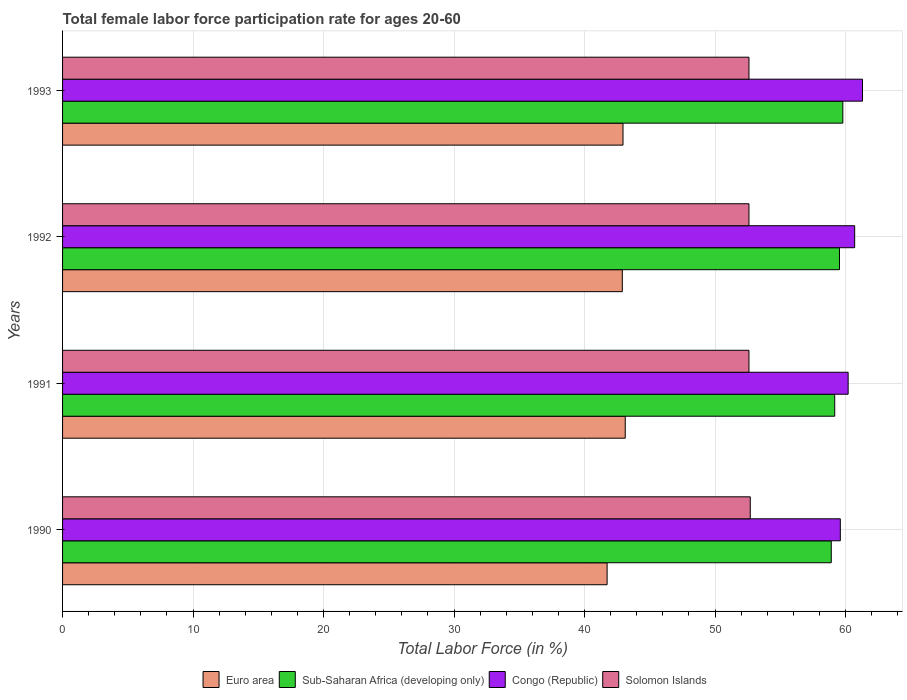How many groups of bars are there?
Provide a succinct answer. 4. Are the number of bars per tick equal to the number of legend labels?
Ensure brevity in your answer.  Yes. How many bars are there on the 1st tick from the top?
Keep it short and to the point. 4. What is the female labor force participation rate in Congo (Republic) in 1992?
Keep it short and to the point. 60.7. Across all years, what is the maximum female labor force participation rate in Euro area?
Provide a short and direct response. 43.12. Across all years, what is the minimum female labor force participation rate in Solomon Islands?
Provide a succinct answer. 52.6. What is the total female labor force participation rate in Congo (Republic) in the graph?
Provide a short and direct response. 241.8. What is the difference between the female labor force participation rate in Sub-Saharan Africa (developing only) in 1990 and that in 1993?
Offer a very short reply. -0.89. What is the difference between the female labor force participation rate in Congo (Republic) in 1990 and the female labor force participation rate in Euro area in 1992?
Give a very brief answer. 16.71. What is the average female labor force participation rate in Congo (Republic) per year?
Make the answer very short. 60.45. In the year 1992, what is the difference between the female labor force participation rate in Sub-Saharan Africa (developing only) and female labor force participation rate in Solomon Islands?
Make the answer very short. 6.94. Is the difference between the female labor force participation rate in Sub-Saharan Africa (developing only) in 1990 and 1993 greater than the difference between the female labor force participation rate in Solomon Islands in 1990 and 1993?
Offer a terse response. No. What is the difference between the highest and the second highest female labor force participation rate in Sub-Saharan Africa (developing only)?
Your response must be concise. 0.26. What is the difference between the highest and the lowest female labor force participation rate in Euro area?
Your response must be concise. 1.39. In how many years, is the female labor force participation rate in Sub-Saharan Africa (developing only) greater than the average female labor force participation rate in Sub-Saharan Africa (developing only) taken over all years?
Offer a terse response. 2. Is the sum of the female labor force participation rate in Sub-Saharan Africa (developing only) in 1990 and 1993 greater than the maximum female labor force participation rate in Euro area across all years?
Your answer should be compact. Yes. Is it the case that in every year, the sum of the female labor force participation rate in Sub-Saharan Africa (developing only) and female labor force participation rate in Congo (Republic) is greater than the sum of female labor force participation rate in Euro area and female labor force participation rate in Solomon Islands?
Give a very brief answer. Yes. What does the 2nd bar from the top in 1993 represents?
Provide a succinct answer. Congo (Republic). What does the 3rd bar from the bottom in 1992 represents?
Keep it short and to the point. Congo (Republic). How many bars are there?
Your answer should be compact. 16. How many years are there in the graph?
Your response must be concise. 4. What is the difference between two consecutive major ticks on the X-axis?
Your response must be concise. 10. Are the values on the major ticks of X-axis written in scientific E-notation?
Keep it short and to the point. No. Does the graph contain any zero values?
Your answer should be compact. No. Does the graph contain grids?
Your answer should be compact. Yes. How many legend labels are there?
Offer a terse response. 4. What is the title of the graph?
Ensure brevity in your answer.  Total female labor force participation rate for ages 20-60. Does "India" appear as one of the legend labels in the graph?
Your response must be concise. No. What is the label or title of the Y-axis?
Offer a very short reply. Years. What is the Total Labor Force (in %) in Euro area in 1990?
Offer a very short reply. 41.73. What is the Total Labor Force (in %) in Sub-Saharan Africa (developing only) in 1990?
Your answer should be very brief. 58.91. What is the Total Labor Force (in %) in Congo (Republic) in 1990?
Make the answer very short. 59.6. What is the Total Labor Force (in %) of Solomon Islands in 1990?
Offer a very short reply. 52.7. What is the Total Labor Force (in %) of Euro area in 1991?
Keep it short and to the point. 43.12. What is the Total Labor Force (in %) in Sub-Saharan Africa (developing only) in 1991?
Make the answer very short. 59.17. What is the Total Labor Force (in %) in Congo (Republic) in 1991?
Your response must be concise. 60.2. What is the Total Labor Force (in %) of Solomon Islands in 1991?
Your answer should be compact. 52.6. What is the Total Labor Force (in %) of Euro area in 1992?
Your response must be concise. 42.89. What is the Total Labor Force (in %) in Sub-Saharan Africa (developing only) in 1992?
Offer a very short reply. 59.54. What is the Total Labor Force (in %) of Congo (Republic) in 1992?
Make the answer very short. 60.7. What is the Total Labor Force (in %) in Solomon Islands in 1992?
Provide a short and direct response. 52.6. What is the Total Labor Force (in %) in Euro area in 1993?
Your answer should be compact. 42.95. What is the Total Labor Force (in %) of Sub-Saharan Africa (developing only) in 1993?
Make the answer very short. 59.79. What is the Total Labor Force (in %) in Congo (Republic) in 1993?
Your answer should be compact. 61.3. What is the Total Labor Force (in %) of Solomon Islands in 1993?
Keep it short and to the point. 52.6. Across all years, what is the maximum Total Labor Force (in %) in Euro area?
Offer a very short reply. 43.12. Across all years, what is the maximum Total Labor Force (in %) in Sub-Saharan Africa (developing only)?
Offer a very short reply. 59.79. Across all years, what is the maximum Total Labor Force (in %) in Congo (Republic)?
Ensure brevity in your answer.  61.3. Across all years, what is the maximum Total Labor Force (in %) of Solomon Islands?
Provide a succinct answer. 52.7. Across all years, what is the minimum Total Labor Force (in %) of Euro area?
Keep it short and to the point. 41.73. Across all years, what is the minimum Total Labor Force (in %) of Sub-Saharan Africa (developing only)?
Ensure brevity in your answer.  58.91. Across all years, what is the minimum Total Labor Force (in %) of Congo (Republic)?
Provide a succinct answer. 59.6. Across all years, what is the minimum Total Labor Force (in %) in Solomon Islands?
Your response must be concise. 52.6. What is the total Total Labor Force (in %) in Euro area in the graph?
Provide a succinct answer. 170.69. What is the total Total Labor Force (in %) of Sub-Saharan Africa (developing only) in the graph?
Your answer should be very brief. 237.41. What is the total Total Labor Force (in %) of Congo (Republic) in the graph?
Your answer should be very brief. 241.8. What is the total Total Labor Force (in %) in Solomon Islands in the graph?
Ensure brevity in your answer.  210.5. What is the difference between the Total Labor Force (in %) in Euro area in 1990 and that in 1991?
Offer a very short reply. -1.39. What is the difference between the Total Labor Force (in %) in Sub-Saharan Africa (developing only) in 1990 and that in 1991?
Offer a very short reply. -0.26. What is the difference between the Total Labor Force (in %) of Congo (Republic) in 1990 and that in 1991?
Ensure brevity in your answer.  -0.6. What is the difference between the Total Labor Force (in %) of Solomon Islands in 1990 and that in 1991?
Offer a terse response. 0.1. What is the difference between the Total Labor Force (in %) of Euro area in 1990 and that in 1992?
Your response must be concise. -1.16. What is the difference between the Total Labor Force (in %) in Sub-Saharan Africa (developing only) in 1990 and that in 1992?
Your answer should be very brief. -0.63. What is the difference between the Total Labor Force (in %) in Congo (Republic) in 1990 and that in 1992?
Keep it short and to the point. -1.1. What is the difference between the Total Labor Force (in %) of Solomon Islands in 1990 and that in 1992?
Make the answer very short. 0.1. What is the difference between the Total Labor Force (in %) in Euro area in 1990 and that in 1993?
Your response must be concise. -1.22. What is the difference between the Total Labor Force (in %) of Sub-Saharan Africa (developing only) in 1990 and that in 1993?
Your response must be concise. -0.89. What is the difference between the Total Labor Force (in %) of Solomon Islands in 1990 and that in 1993?
Your answer should be compact. 0.1. What is the difference between the Total Labor Force (in %) in Euro area in 1991 and that in 1992?
Offer a terse response. 0.22. What is the difference between the Total Labor Force (in %) in Sub-Saharan Africa (developing only) in 1991 and that in 1992?
Offer a terse response. -0.36. What is the difference between the Total Labor Force (in %) of Solomon Islands in 1991 and that in 1992?
Make the answer very short. 0. What is the difference between the Total Labor Force (in %) of Euro area in 1991 and that in 1993?
Your answer should be compact. 0.17. What is the difference between the Total Labor Force (in %) of Sub-Saharan Africa (developing only) in 1991 and that in 1993?
Your response must be concise. -0.62. What is the difference between the Total Labor Force (in %) in Solomon Islands in 1991 and that in 1993?
Ensure brevity in your answer.  0. What is the difference between the Total Labor Force (in %) in Euro area in 1992 and that in 1993?
Ensure brevity in your answer.  -0.05. What is the difference between the Total Labor Force (in %) of Sub-Saharan Africa (developing only) in 1992 and that in 1993?
Provide a succinct answer. -0.26. What is the difference between the Total Labor Force (in %) in Congo (Republic) in 1992 and that in 1993?
Ensure brevity in your answer.  -0.6. What is the difference between the Total Labor Force (in %) of Solomon Islands in 1992 and that in 1993?
Provide a succinct answer. 0. What is the difference between the Total Labor Force (in %) in Euro area in 1990 and the Total Labor Force (in %) in Sub-Saharan Africa (developing only) in 1991?
Your answer should be compact. -17.44. What is the difference between the Total Labor Force (in %) in Euro area in 1990 and the Total Labor Force (in %) in Congo (Republic) in 1991?
Provide a short and direct response. -18.47. What is the difference between the Total Labor Force (in %) in Euro area in 1990 and the Total Labor Force (in %) in Solomon Islands in 1991?
Offer a very short reply. -10.87. What is the difference between the Total Labor Force (in %) in Sub-Saharan Africa (developing only) in 1990 and the Total Labor Force (in %) in Congo (Republic) in 1991?
Make the answer very short. -1.29. What is the difference between the Total Labor Force (in %) in Sub-Saharan Africa (developing only) in 1990 and the Total Labor Force (in %) in Solomon Islands in 1991?
Give a very brief answer. 6.31. What is the difference between the Total Labor Force (in %) in Congo (Republic) in 1990 and the Total Labor Force (in %) in Solomon Islands in 1991?
Offer a terse response. 7. What is the difference between the Total Labor Force (in %) of Euro area in 1990 and the Total Labor Force (in %) of Sub-Saharan Africa (developing only) in 1992?
Keep it short and to the point. -17.81. What is the difference between the Total Labor Force (in %) in Euro area in 1990 and the Total Labor Force (in %) in Congo (Republic) in 1992?
Keep it short and to the point. -18.97. What is the difference between the Total Labor Force (in %) in Euro area in 1990 and the Total Labor Force (in %) in Solomon Islands in 1992?
Your answer should be very brief. -10.87. What is the difference between the Total Labor Force (in %) in Sub-Saharan Africa (developing only) in 1990 and the Total Labor Force (in %) in Congo (Republic) in 1992?
Provide a succinct answer. -1.79. What is the difference between the Total Labor Force (in %) of Sub-Saharan Africa (developing only) in 1990 and the Total Labor Force (in %) of Solomon Islands in 1992?
Make the answer very short. 6.31. What is the difference between the Total Labor Force (in %) of Euro area in 1990 and the Total Labor Force (in %) of Sub-Saharan Africa (developing only) in 1993?
Provide a short and direct response. -18.06. What is the difference between the Total Labor Force (in %) in Euro area in 1990 and the Total Labor Force (in %) in Congo (Republic) in 1993?
Keep it short and to the point. -19.57. What is the difference between the Total Labor Force (in %) in Euro area in 1990 and the Total Labor Force (in %) in Solomon Islands in 1993?
Make the answer very short. -10.87. What is the difference between the Total Labor Force (in %) of Sub-Saharan Africa (developing only) in 1990 and the Total Labor Force (in %) of Congo (Republic) in 1993?
Give a very brief answer. -2.39. What is the difference between the Total Labor Force (in %) in Sub-Saharan Africa (developing only) in 1990 and the Total Labor Force (in %) in Solomon Islands in 1993?
Your response must be concise. 6.31. What is the difference between the Total Labor Force (in %) in Euro area in 1991 and the Total Labor Force (in %) in Sub-Saharan Africa (developing only) in 1992?
Offer a very short reply. -16.42. What is the difference between the Total Labor Force (in %) in Euro area in 1991 and the Total Labor Force (in %) in Congo (Republic) in 1992?
Keep it short and to the point. -17.58. What is the difference between the Total Labor Force (in %) of Euro area in 1991 and the Total Labor Force (in %) of Solomon Islands in 1992?
Give a very brief answer. -9.48. What is the difference between the Total Labor Force (in %) in Sub-Saharan Africa (developing only) in 1991 and the Total Labor Force (in %) in Congo (Republic) in 1992?
Your response must be concise. -1.53. What is the difference between the Total Labor Force (in %) in Sub-Saharan Africa (developing only) in 1991 and the Total Labor Force (in %) in Solomon Islands in 1992?
Offer a very short reply. 6.57. What is the difference between the Total Labor Force (in %) of Congo (Republic) in 1991 and the Total Labor Force (in %) of Solomon Islands in 1992?
Your answer should be very brief. 7.6. What is the difference between the Total Labor Force (in %) of Euro area in 1991 and the Total Labor Force (in %) of Sub-Saharan Africa (developing only) in 1993?
Ensure brevity in your answer.  -16.67. What is the difference between the Total Labor Force (in %) of Euro area in 1991 and the Total Labor Force (in %) of Congo (Republic) in 1993?
Make the answer very short. -18.18. What is the difference between the Total Labor Force (in %) in Euro area in 1991 and the Total Labor Force (in %) in Solomon Islands in 1993?
Your answer should be very brief. -9.48. What is the difference between the Total Labor Force (in %) of Sub-Saharan Africa (developing only) in 1991 and the Total Labor Force (in %) of Congo (Republic) in 1993?
Your response must be concise. -2.13. What is the difference between the Total Labor Force (in %) of Sub-Saharan Africa (developing only) in 1991 and the Total Labor Force (in %) of Solomon Islands in 1993?
Give a very brief answer. 6.57. What is the difference between the Total Labor Force (in %) in Congo (Republic) in 1991 and the Total Labor Force (in %) in Solomon Islands in 1993?
Give a very brief answer. 7.6. What is the difference between the Total Labor Force (in %) in Euro area in 1992 and the Total Labor Force (in %) in Sub-Saharan Africa (developing only) in 1993?
Offer a very short reply. -16.9. What is the difference between the Total Labor Force (in %) in Euro area in 1992 and the Total Labor Force (in %) in Congo (Republic) in 1993?
Offer a very short reply. -18.41. What is the difference between the Total Labor Force (in %) in Euro area in 1992 and the Total Labor Force (in %) in Solomon Islands in 1993?
Keep it short and to the point. -9.71. What is the difference between the Total Labor Force (in %) of Sub-Saharan Africa (developing only) in 1992 and the Total Labor Force (in %) of Congo (Republic) in 1993?
Make the answer very short. -1.76. What is the difference between the Total Labor Force (in %) in Sub-Saharan Africa (developing only) in 1992 and the Total Labor Force (in %) in Solomon Islands in 1993?
Offer a terse response. 6.94. What is the average Total Labor Force (in %) of Euro area per year?
Your response must be concise. 42.67. What is the average Total Labor Force (in %) in Sub-Saharan Africa (developing only) per year?
Keep it short and to the point. 59.35. What is the average Total Labor Force (in %) in Congo (Republic) per year?
Your answer should be compact. 60.45. What is the average Total Labor Force (in %) of Solomon Islands per year?
Your answer should be compact. 52.62. In the year 1990, what is the difference between the Total Labor Force (in %) of Euro area and Total Labor Force (in %) of Sub-Saharan Africa (developing only)?
Your response must be concise. -17.18. In the year 1990, what is the difference between the Total Labor Force (in %) of Euro area and Total Labor Force (in %) of Congo (Republic)?
Your response must be concise. -17.87. In the year 1990, what is the difference between the Total Labor Force (in %) of Euro area and Total Labor Force (in %) of Solomon Islands?
Your answer should be very brief. -10.97. In the year 1990, what is the difference between the Total Labor Force (in %) of Sub-Saharan Africa (developing only) and Total Labor Force (in %) of Congo (Republic)?
Ensure brevity in your answer.  -0.69. In the year 1990, what is the difference between the Total Labor Force (in %) of Sub-Saharan Africa (developing only) and Total Labor Force (in %) of Solomon Islands?
Make the answer very short. 6.21. In the year 1991, what is the difference between the Total Labor Force (in %) in Euro area and Total Labor Force (in %) in Sub-Saharan Africa (developing only)?
Your answer should be compact. -16.05. In the year 1991, what is the difference between the Total Labor Force (in %) of Euro area and Total Labor Force (in %) of Congo (Republic)?
Ensure brevity in your answer.  -17.08. In the year 1991, what is the difference between the Total Labor Force (in %) in Euro area and Total Labor Force (in %) in Solomon Islands?
Provide a succinct answer. -9.48. In the year 1991, what is the difference between the Total Labor Force (in %) of Sub-Saharan Africa (developing only) and Total Labor Force (in %) of Congo (Republic)?
Provide a short and direct response. -1.03. In the year 1991, what is the difference between the Total Labor Force (in %) of Sub-Saharan Africa (developing only) and Total Labor Force (in %) of Solomon Islands?
Provide a short and direct response. 6.57. In the year 1991, what is the difference between the Total Labor Force (in %) in Congo (Republic) and Total Labor Force (in %) in Solomon Islands?
Make the answer very short. 7.6. In the year 1992, what is the difference between the Total Labor Force (in %) in Euro area and Total Labor Force (in %) in Sub-Saharan Africa (developing only)?
Offer a very short reply. -16.64. In the year 1992, what is the difference between the Total Labor Force (in %) in Euro area and Total Labor Force (in %) in Congo (Republic)?
Your response must be concise. -17.81. In the year 1992, what is the difference between the Total Labor Force (in %) of Euro area and Total Labor Force (in %) of Solomon Islands?
Your answer should be very brief. -9.71. In the year 1992, what is the difference between the Total Labor Force (in %) of Sub-Saharan Africa (developing only) and Total Labor Force (in %) of Congo (Republic)?
Make the answer very short. -1.16. In the year 1992, what is the difference between the Total Labor Force (in %) of Sub-Saharan Africa (developing only) and Total Labor Force (in %) of Solomon Islands?
Your answer should be compact. 6.94. In the year 1993, what is the difference between the Total Labor Force (in %) of Euro area and Total Labor Force (in %) of Sub-Saharan Africa (developing only)?
Provide a short and direct response. -16.85. In the year 1993, what is the difference between the Total Labor Force (in %) of Euro area and Total Labor Force (in %) of Congo (Republic)?
Your answer should be very brief. -18.35. In the year 1993, what is the difference between the Total Labor Force (in %) of Euro area and Total Labor Force (in %) of Solomon Islands?
Keep it short and to the point. -9.65. In the year 1993, what is the difference between the Total Labor Force (in %) in Sub-Saharan Africa (developing only) and Total Labor Force (in %) in Congo (Republic)?
Offer a very short reply. -1.51. In the year 1993, what is the difference between the Total Labor Force (in %) of Sub-Saharan Africa (developing only) and Total Labor Force (in %) of Solomon Islands?
Provide a short and direct response. 7.19. In the year 1993, what is the difference between the Total Labor Force (in %) of Congo (Republic) and Total Labor Force (in %) of Solomon Islands?
Give a very brief answer. 8.7. What is the ratio of the Total Labor Force (in %) in Euro area in 1990 to that in 1991?
Provide a succinct answer. 0.97. What is the ratio of the Total Labor Force (in %) in Sub-Saharan Africa (developing only) in 1990 to that in 1991?
Ensure brevity in your answer.  1. What is the ratio of the Total Labor Force (in %) in Congo (Republic) in 1990 to that in 1991?
Offer a very short reply. 0.99. What is the ratio of the Total Labor Force (in %) of Solomon Islands in 1990 to that in 1991?
Your answer should be very brief. 1. What is the ratio of the Total Labor Force (in %) in Euro area in 1990 to that in 1992?
Your answer should be compact. 0.97. What is the ratio of the Total Labor Force (in %) of Sub-Saharan Africa (developing only) in 1990 to that in 1992?
Provide a short and direct response. 0.99. What is the ratio of the Total Labor Force (in %) in Congo (Republic) in 1990 to that in 1992?
Give a very brief answer. 0.98. What is the ratio of the Total Labor Force (in %) in Euro area in 1990 to that in 1993?
Offer a very short reply. 0.97. What is the ratio of the Total Labor Force (in %) in Sub-Saharan Africa (developing only) in 1990 to that in 1993?
Offer a very short reply. 0.99. What is the ratio of the Total Labor Force (in %) of Congo (Republic) in 1990 to that in 1993?
Your answer should be compact. 0.97. What is the ratio of the Total Labor Force (in %) in Euro area in 1991 to that in 1992?
Make the answer very short. 1.01. What is the ratio of the Total Labor Force (in %) in Sub-Saharan Africa (developing only) in 1991 to that in 1992?
Offer a terse response. 0.99. What is the ratio of the Total Labor Force (in %) in Congo (Republic) in 1991 to that in 1992?
Keep it short and to the point. 0.99. What is the ratio of the Total Labor Force (in %) in Congo (Republic) in 1991 to that in 1993?
Your answer should be very brief. 0.98. What is the ratio of the Total Labor Force (in %) of Solomon Islands in 1991 to that in 1993?
Provide a succinct answer. 1. What is the ratio of the Total Labor Force (in %) in Euro area in 1992 to that in 1993?
Offer a very short reply. 1. What is the ratio of the Total Labor Force (in %) in Sub-Saharan Africa (developing only) in 1992 to that in 1993?
Make the answer very short. 1. What is the ratio of the Total Labor Force (in %) in Congo (Republic) in 1992 to that in 1993?
Provide a short and direct response. 0.99. What is the ratio of the Total Labor Force (in %) of Solomon Islands in 1992 to that in 1993?
Provide a short and direct response. 1. What is the difference between the highest and the second highest Total Labor Force (in %) in Euro area?
Your answer should be compact. 0.17. What is the difference between the highest and the second highest Total Labor Force (in %) of Sub-Saharan Africa (developing only)?
Make the answer very short. 0.26. What is the difference between the highest and the lowest Total Labor Force (in %) of Euro area?
Your answer should be very brief. 1.39. What is the difference between the highest and the lowest Total Labor Force (in %) in Sub-Saharan Africa (developing only)?
Keep it short and to the point. 0.89. What is the difference between the highest and the lowest Total Labor Force (in %) in Congo (Republic)?
Ensure brevity in your answer.  1.7. 